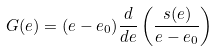Convert formula to latex. <formula><loc_0><loc_0><loc_500><loc_500>G ( e ) = ( e - e _ { 0 } ) \frac { d } { d e } \left ( \frac { s ( e ) } { e - e _ { 0 } } \right )</formula> 